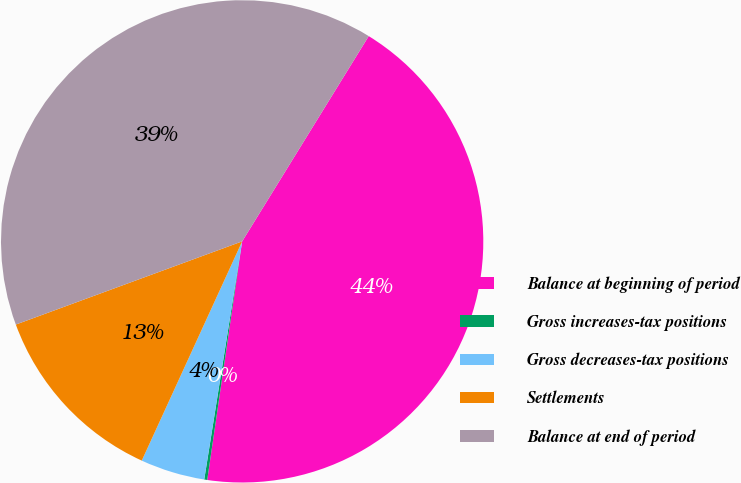Convert chart to OTSL. <chart><loc_0><loc_0><loc_500><loc_500><pie_chart><fcel>Balance at beginning of period<fcel>Gross increases-tax positions<fcel>Gross decreases-tax positions<fcel>Settlements<fcel>Balance at end of period<nl><fcel>43.52%<fcel>0.2%<fcel>4.32%<fcel>12.56%<fcel>39.4%<nl></chart> 